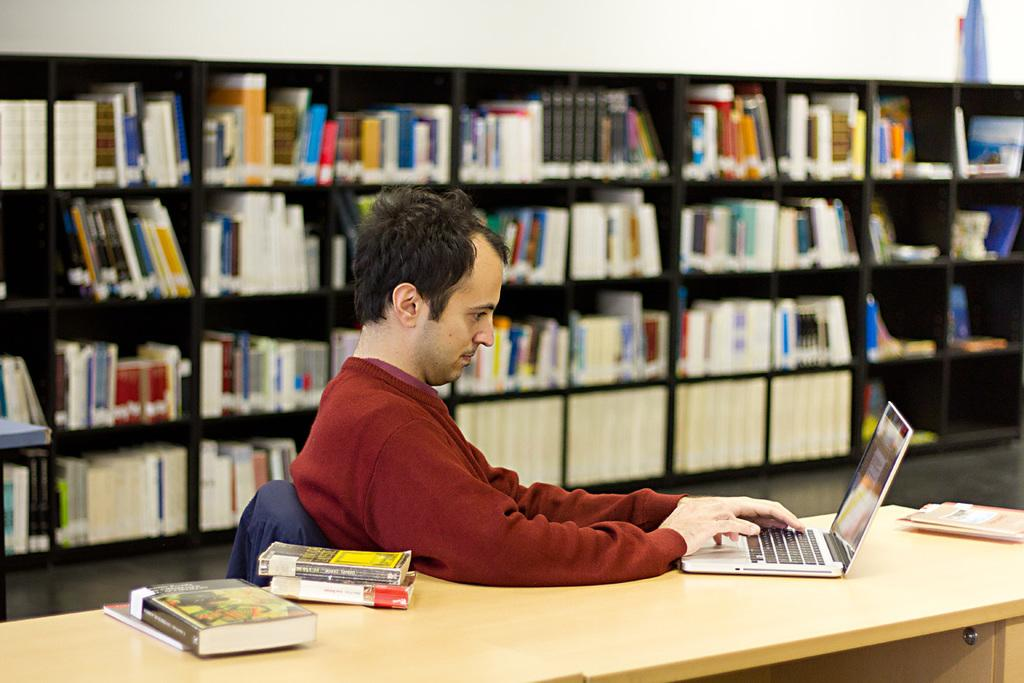What is the person in the image doing? The person is sitting on a chair. What is on the table in the image? There is a laptop and books on the table. Can you describe the background of the image? There is a cupboard in the background. What is on the cupboard? There are books on the cupboard. What type of camera can be seen in the image? There is no camera present in the image. What time of day is it in the image? The time of day cannot be determined from the image. 